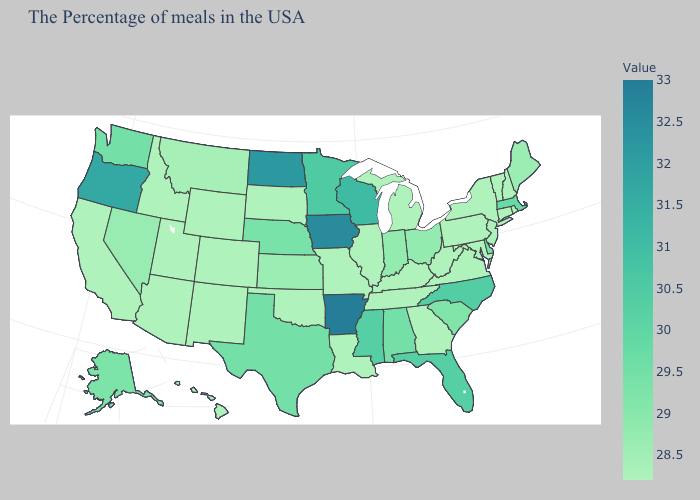Does the map have missing data?
Give a very brief answer. No. Does the map have missing data?
Give a very brief answer. No. Is the legend a continuous bar?
Write a very short answer. Yes. Does Massachusetts have the highest value in the USA?
Answer briefly. No. Does the map have missing data?
Quick response, please. No. Among the states that border Michigan , does Wisconsin have the highest value?
Answer briefly. Yes. Does Michigan have the highest value in the USA?
Short answer required. No. Does the map have missing data?
Keep it brief. No. 